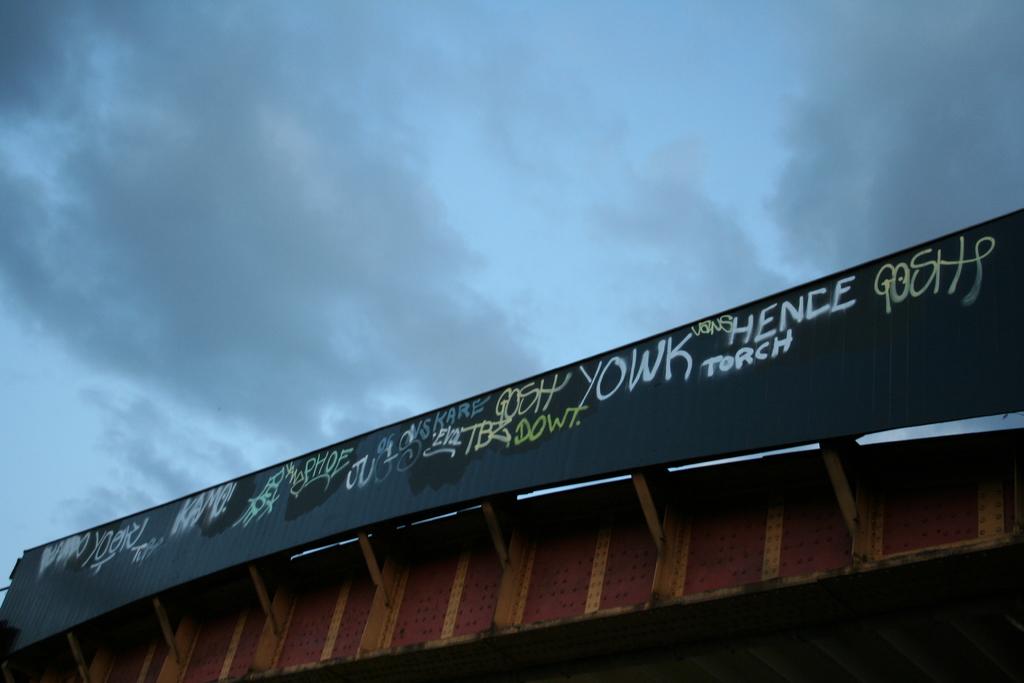What word is to the left of "hence" in white lettering?
Your answer should be compact. Yowk. 